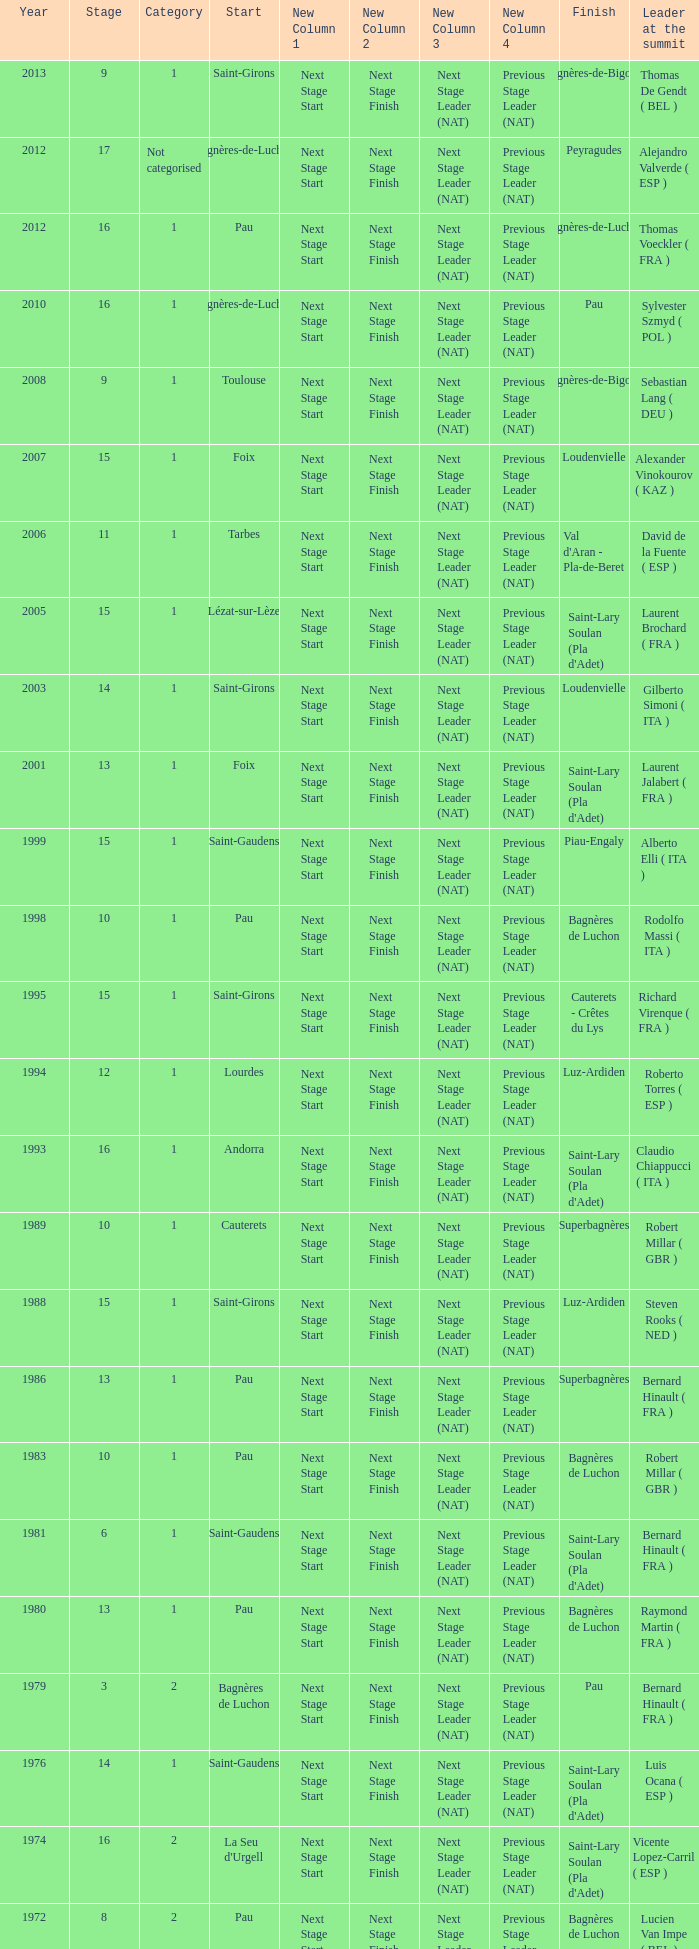What stage has a start of saint-girons in 1988? 15.0. 